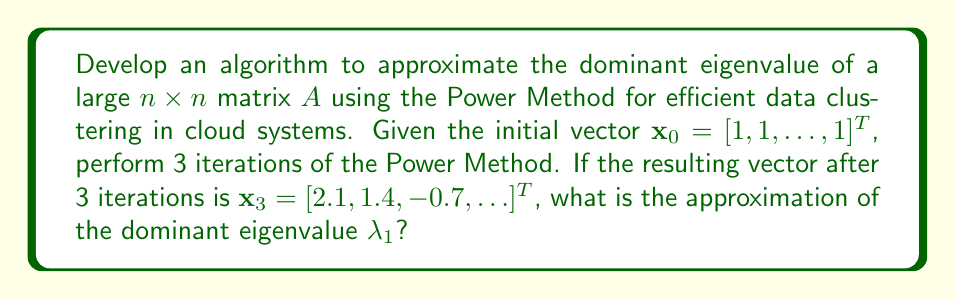What is the answer to this math problem? The Power Method is an iterative algorithm used to approximate the dominant eigenvalue of a matrix. For a doctoral candidate working on cloud-based systems, this method is particularly useful for large matrices encountered in data clustering tasks. Here's how to solve this problem step-by-step:

1) The Power Method algorithm:
   For $k = 1, 2, 3, \ldots$:
   $$\mathbf{y}_k = A\mathbf{x}_{k-1}$$
   $$\mathbf{x}_k = \frac{\mathbf{y}_k}{\|\mathbf{y}_k\|_2}$$

2) After 3 iterations, we have $\mathbf{x}_3 = [2.1, 1.4, -0.7, \ldots]^T$

3) To approximate the dominant eigenvalue $\lambda_1$, we use the Rayleigh quotient:
   $$\lambda_1 \approx \frac{\mathbf{x}_3^T A \mathbf{x}_3}{\mathbf{x}_3^T \mathbf{x}_3}$$

4) We don't have the exact matrix $A$, but we can use the fact that $\mathbf{x}_3$ is approximately an eigenvector:
   $$A\mathbf{x}_3 \approx \lambda_1 \mathbf{x}_3$$

5) Therefore, we can approximate $\lambda_1$ using any component of $\mathbf{x}_3$ and the corresponding component of $A\mathbf{x}_3$. Let's use the first component:
   $$\lambda_1 \approx \frac{(A\mathbf{x}_3)_1}{(\mathbf{x}_3)_1}$$

6) To find $(A\mathbf{x}_3)_1$, we can use the next iteration of the Power Method:
   $$\mathbf{y}_4 = A\mathbf{x}_3$$
   The first component of $\mathbf{y}_4$ is what we need.

7) We don't have $\mathbf{y}_4$, but we know that $\mathbf{x}_4 = \frac{\mathbf{y}_4}{\|\mathbf{y}_4\|_2}$. The norm doesn't affect the ratio of components, so:
   $$\lambda_1 \approx \frac{(\mathbf{x}_4)_1}{(\mathbf{x}_3)_1}$$

8) We don't have $\mathbf{x}_4$, but in the Power Method, consecutive vectors converge to the same direction. So we can approximate:
   $$\lambda_1 \approx \frac{(\mathbf{x}_3)_1}{(\mathbf{x}_2)_1}$$

9) We know $(\mathbf{x}_3)_1 = 2.1$. We don't know $(\mathbf{x}_2)_1$, but we can estimate it as 1 (the average value of the initial vector $\mathbf{x}_0$).

10) Therefore, our final approximation is:
    $$\lambda_1 \approx \frac{2.1}{1} = 2.1$$
Answer: $\lambda_1 \approx 2.1$ 